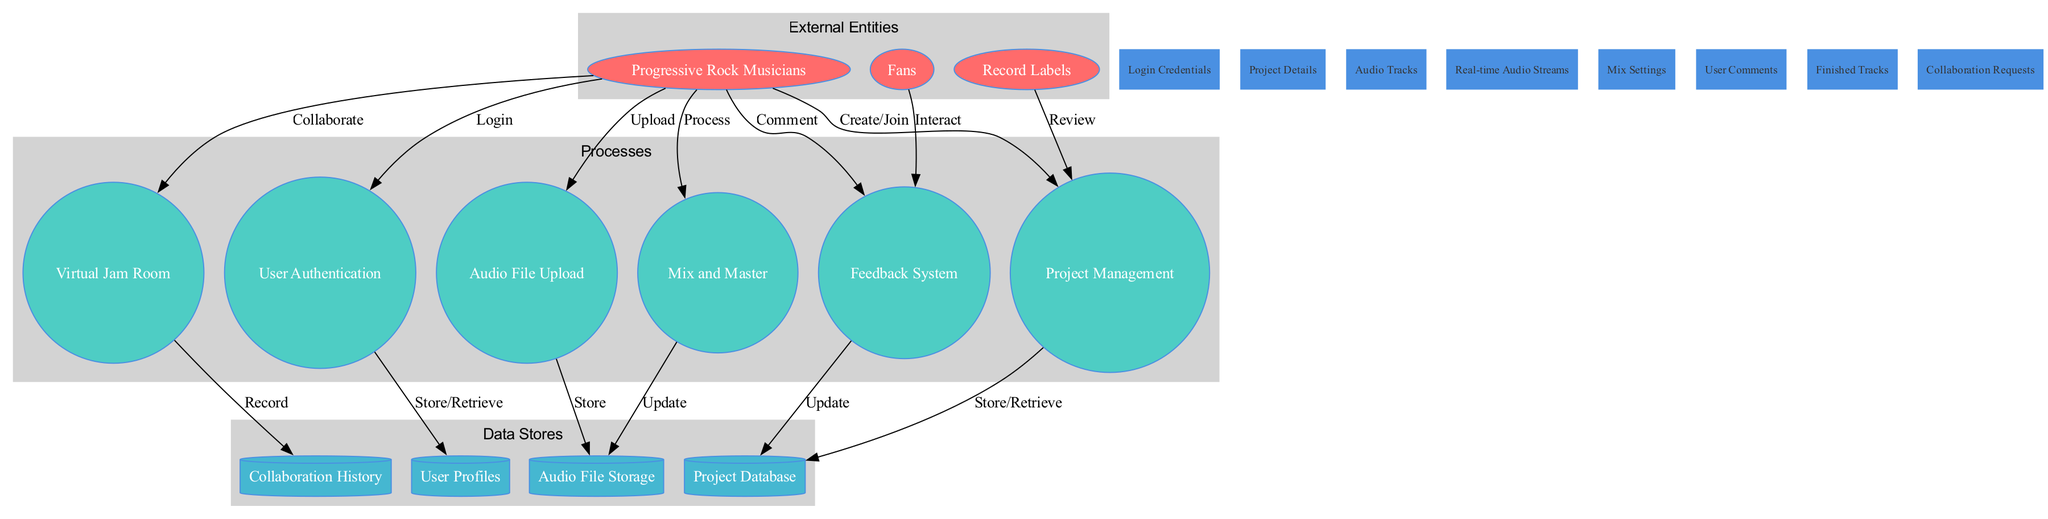What's the total number of external entities in the diagram? There are three external entities listed: Progressive Rock Musicians, Fans, and Record Labels. Therefore, counting them gives a total of three.
Answer: 3 Which process is involved in storing user information? The User Authentication process is responsible for storing and retrieving user information in the User Profiles data store.
Answer: User Authentication What data store is related to audio uploads? The Audio File Storage data store stores the audio files uploaded by the users through the Audio File Upload process.
Answer: Audio File Storage How many data flows are present in the diagram? The data flows that are defined include Login Credentials, Project Details, Audio Tracks, Real-time Audio Streams, Mix Settings, User Comments, Finished Tracks, and Collaboration Requests. Counting these, there are a total of eight data flows.
Answer: 8 Which external entity interacts with the Feedback System? Both Fans and Progressive Rock Musicians interact with the Feedback System; however, the question specifically states "interact," which refers to Feedback Requests initiated by Fans.
Answer: Fans What is the role of the Virtual Jam Room in the diagram? The Virtual Jam Room serves as a collaborative environment where Progressive Rock Musicians can work together, recording their sessions and establishing Collaboration History.
Answer: Collaborate Which process would be engaged when mixing audio tracks? The process involved in mixing audio tracks is called Mix and Master, which modifies and finalizes the audio files before they are stored.
Answer: Mix and Master Which data flow connects Progressive Rock Musicians to the Project Management process? The connection made is through Project Details, allowing Progressive Rock Musicians to create or join projects.
Answer: Project Details How does the Feedback System contribute to the Project Database? The Feedback System updates the Project Database by documenting user comments and interactions which can influence future project decisions.
Answer: Update 